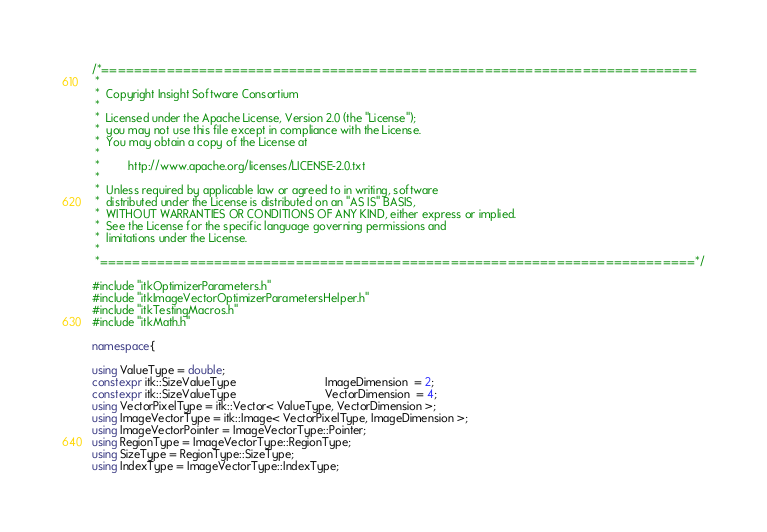<code> <loc_0><loc_0><loc_500><loc_500><_C++_>/*=========================================================================
 *
 *  Copyright Insight Software Consortium
 *
 *  Licensed under the Apache License, Version 2.0 (the "License");
 *  you may not use this file except in compliance with the License.
 *  You may obtain a copy of the License at
 *
 *         http://www.apache.org/licenses/LICENSE-2.0.txt
 *
 *  Unless required by applicable law or agreed to in writing, software
 *  distributed under the License is distributed on an "AS IS" BASIS,
 *  WITHOUT WARRANTIES OR CONDITIONS OF ANY KIND, either express or implied.
 *  See the License for the specific language governing permissions and
 *  limitations under the License.
 *
 *=========================================================================*/

#include "itkOptimizerParameters.h"
#include "itkImageVectorOptimizerParametersHelper.h"
#include "itkTestingMacros.h"
#include "itkMath.h"

namespace{

using ValueType = double;
constexpr itk::SizeValueType                            ImageDimension  = 2;
constexpr itk::SizeValueType                            VectorDimension  = 4;
using VectorPixelType = itk::Vector< ValueType, VectorDimension >;
using ImageVectorType = itk::Image< VectorPixelType, ImageDimension >;
using ImageVectorPointer = ImageVectorType::Pointer;
using RegionType = ImageVectorType::RegionType;
using SizeType = RegionType::SizeType;
using IndexType = ImageVectorType::IndexType;</code> 